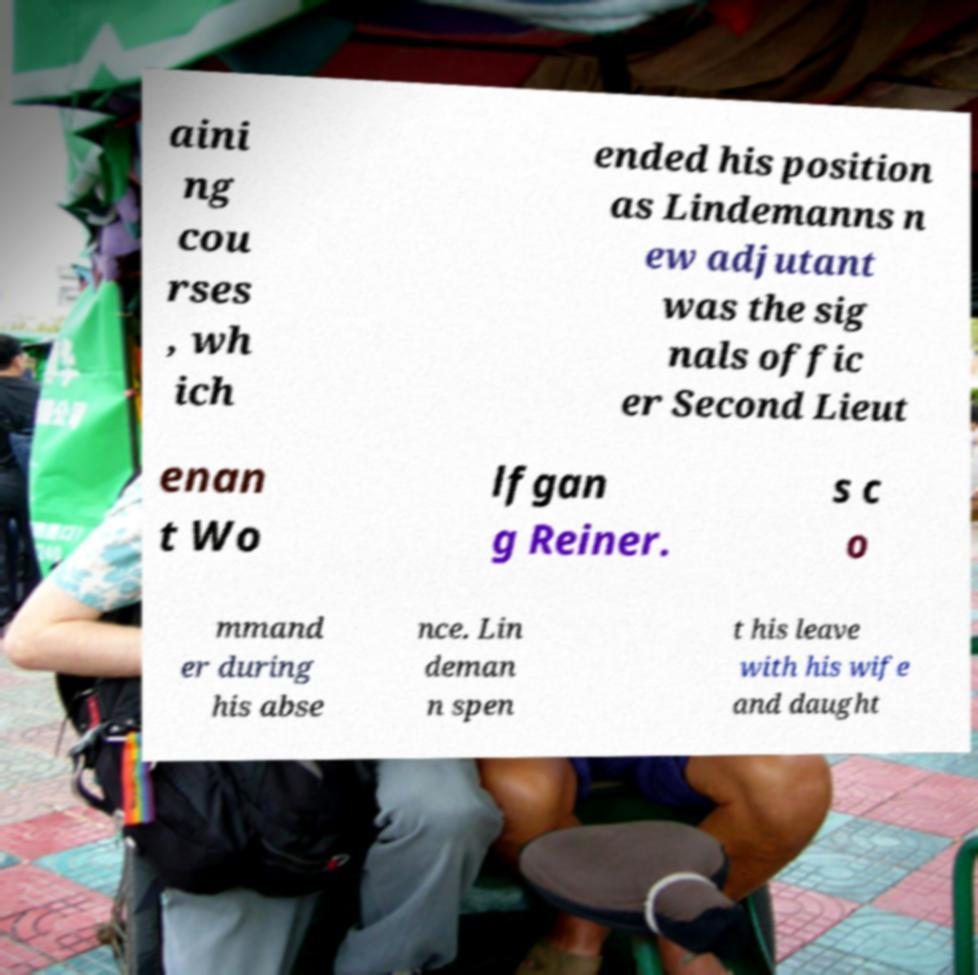Could you assist in decoding the text presented in this image and type it out clearly? aini ng cou rses , wh ich ended his position as Lindemanns n ew adjutant was the sig nals offic er Second Lieut enan t Wo lfgan g Reiner. s c o mmand er during his abse nce. Lin deman n spen t his leave with his wife and daught 